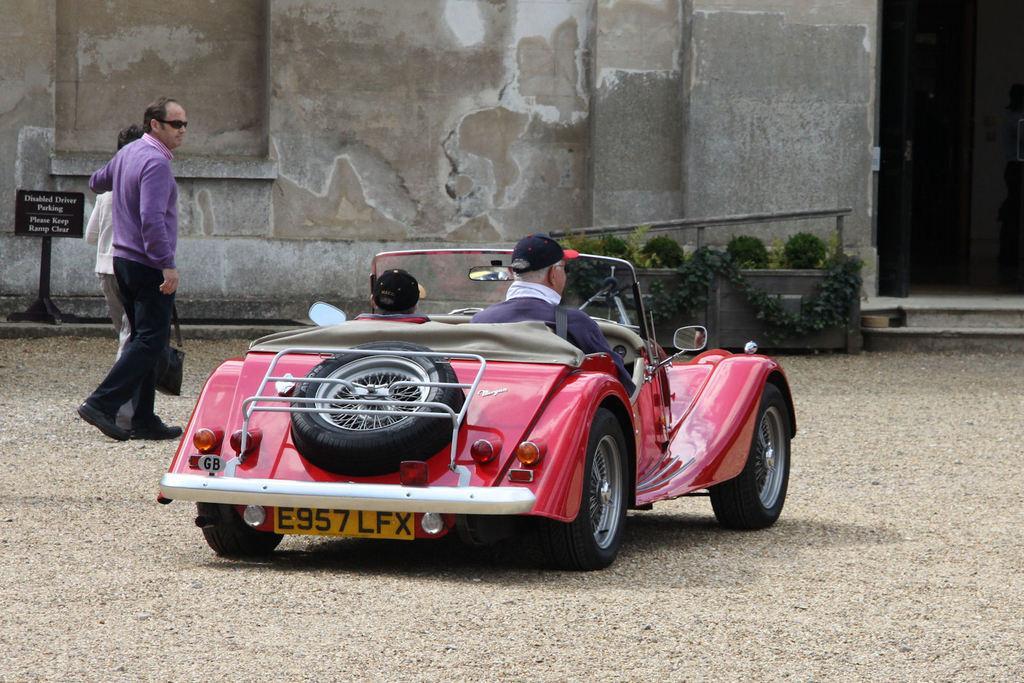In one or two sentences, can you explain what this image depicts? Two people are driving a car passing by a couple standing. 